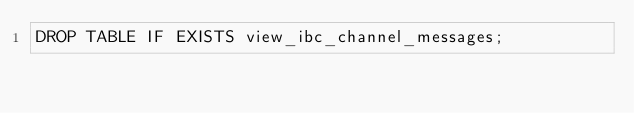Convert code to text. <code><loc_0><loc_0><loc_500><loc_500><_SQL_>DROP TABLE IF EXISTS view_ibc_channel_messages;</code> 